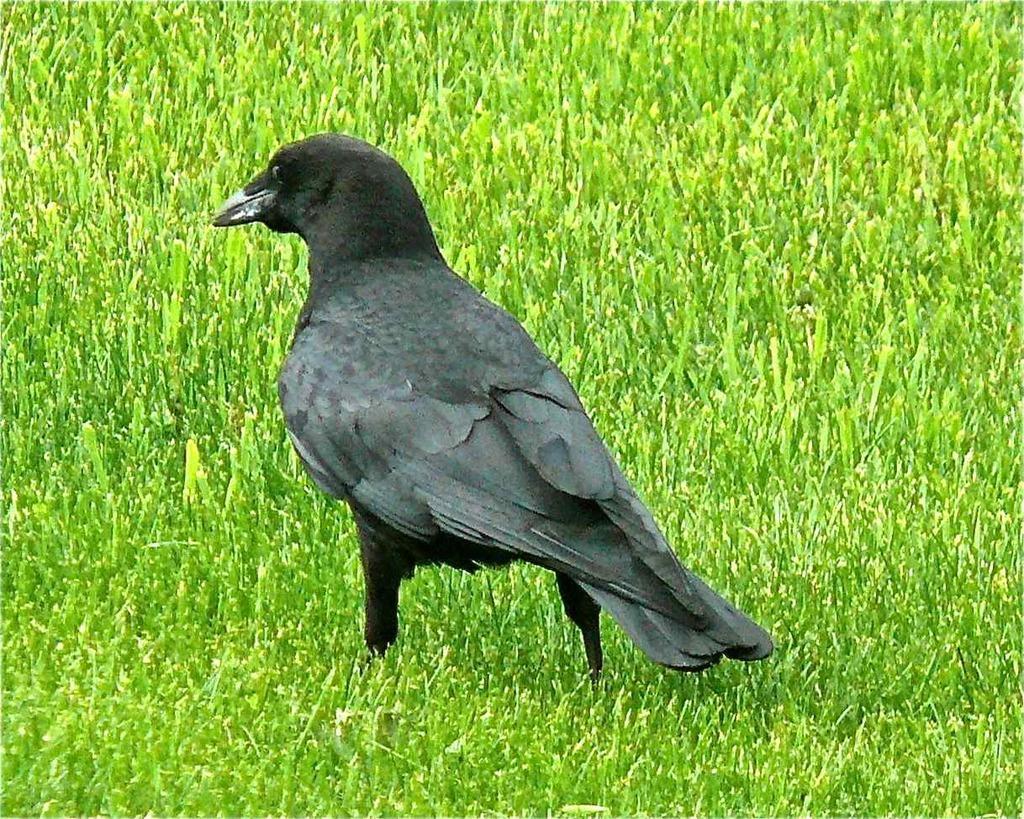How would you summarize this image in a sentence or two? In this picture I can see a bird on the grass. 